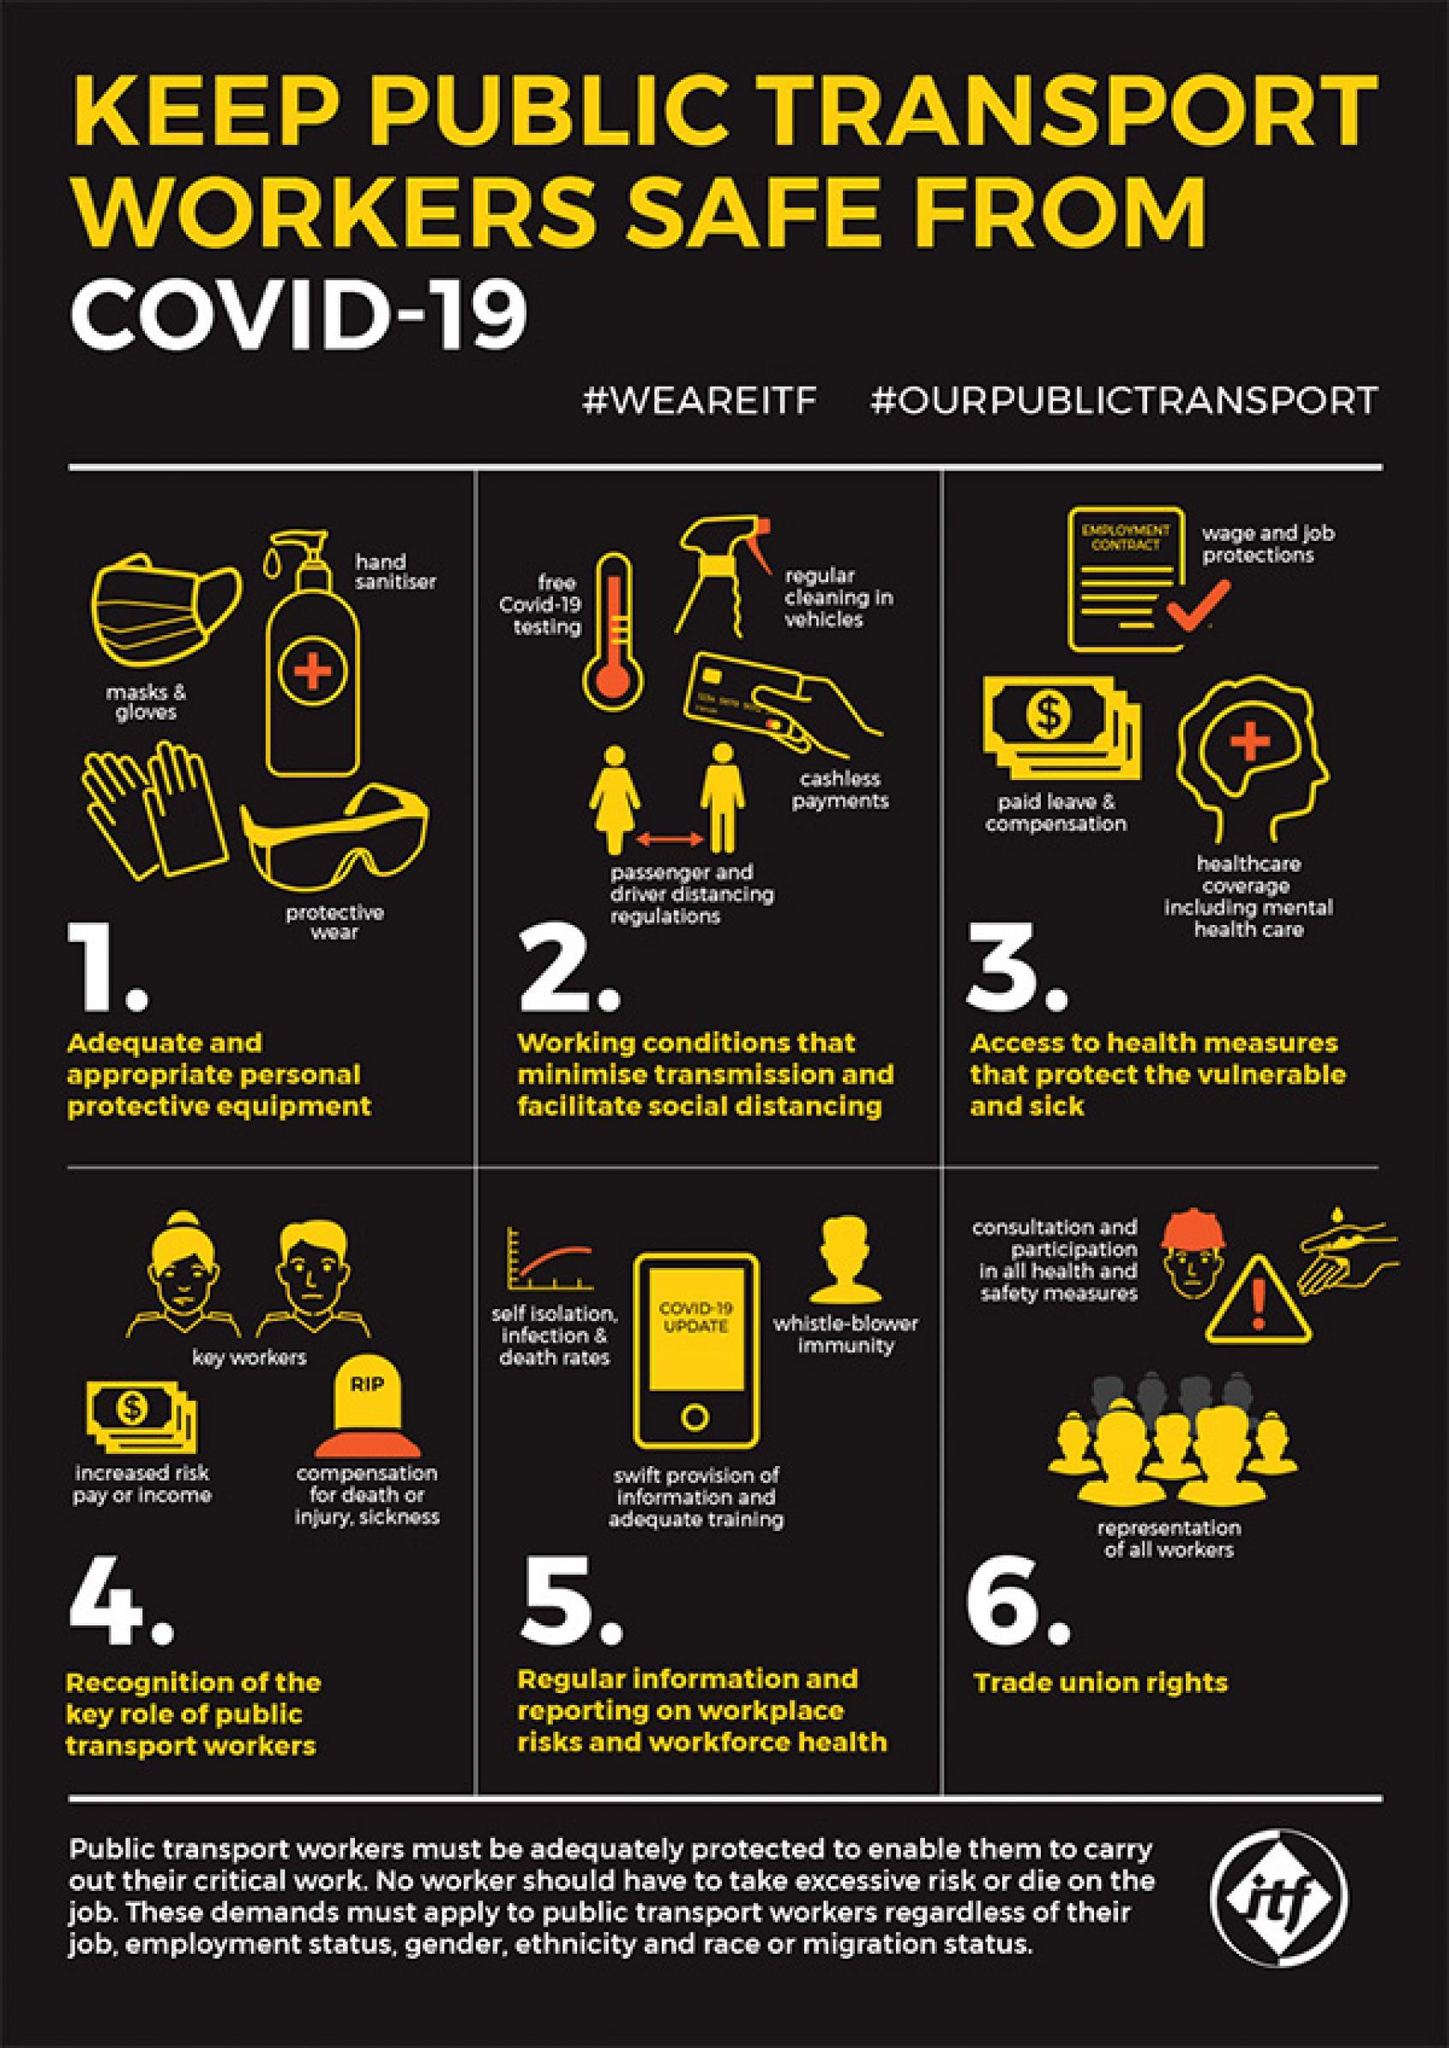What is written on the screen of the smart phone
Answer the question with a short phrase. COVID-19 UPDATE what is written on the headstone RIP what does the spray bottle / nozzle indicate regular cleaning in vehicles representation of all workers come under which demand trade union rights what are the trade union rights consultation and participation in all health and safety measures, representation of all workers what are the requirements that the currency note indicate paid leave & compensation, increased risk pay or income What are the PPE shown in point 1 masks & gloves, hand sanitiser, protective wear What are the 2 hashtags #WEAREITF, #OURPUBLICTRANSPORT 